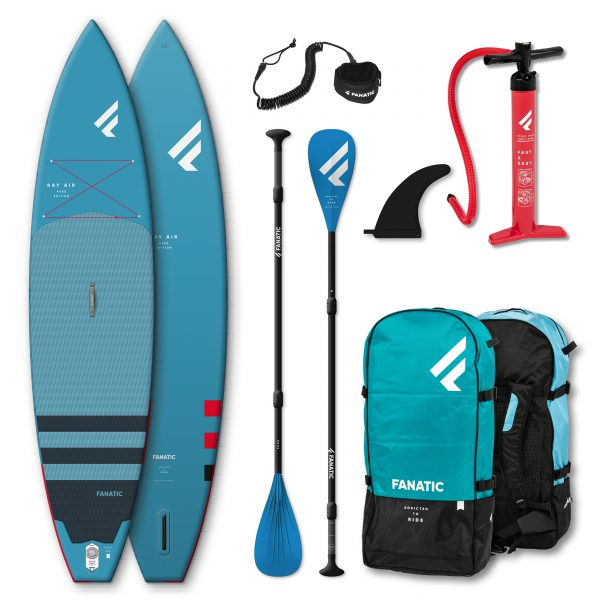Imagine if these paddleboards were used in a paddleboarding competition. What additional features or equipment might be needed? In a paddleboarding competition, competitors might require additional features and equipment such as high-performance paddles for better speed and efficiency, a more streamlined and lightweight paddleboard optimized for racing, hydration packs to stay hydrated during the race, and timing devices to keep track of their performance. Competitors might also wear specialized racing gear, including wetsuits or rash guards, for enhanced comfort and protection. Safety equipment, including PFDs, would still be essential, and race organizers might also require participants to use leashes to prevent the boards from drifting away if they fall off. 